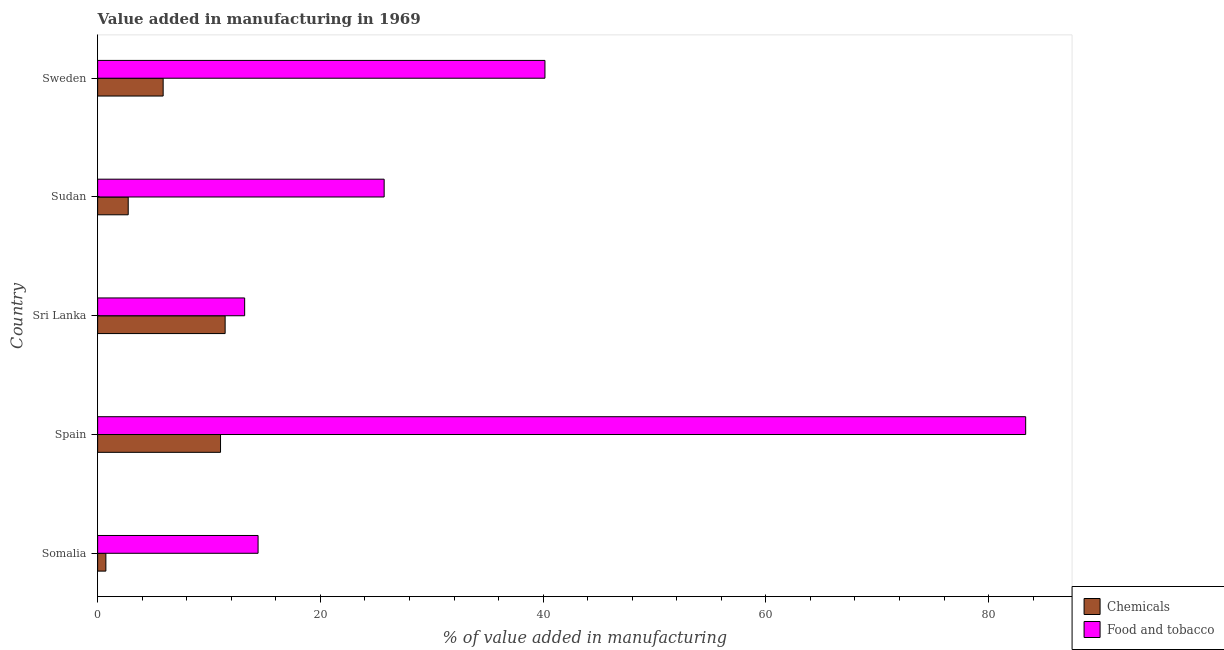How many different coloured bars are there?
Offer a terse response. 2. How many groups of bars are there?
Make the answer very short. 5. What is the label of the 5th group of bars from the top?
Keep it short and to the point. Somalia. In how many cases, is the number of bars for a given country not equal to the number of legend labels?
Your answer should be very brief. 0. What is the value added by  manufacturing chemicals in Spain?
Keep it short and to the point. 11.03. Across all countries, what is the maximum value added by  manufacturing chemicals?
Offer a terse response. 11.45. Across all countries, what is the minimum value added by manufacturing food and tobacco?
Offer a terse response. 13.2. In which country was the value added by manufacturing food and tobacco maximum?
Provide a succinct answer. Spain. In which country was the value added by manufacturing food and tobacco minimum?
Provide a short and direct response. Sri Lanka. What is the total value added by  manufacturing chemicals in the graph?
Your answer should be very brief. 31.85. What is the difference between the value added by manufacturing food and tobacco in Sri Lanka and that in Sweden?
Offer a very short reply. -26.96. What is the difference between the value added by manufacturing food and tobacco in Somalia and the value added by  manufacturing chemicals in Sudan?
Give a very brief answer. 11.66. What is the average value added by  manufacturing chemicals per country?
Provide a succinct answer. 6.37. What is the difference between the value added by  manufacturing chemicals and value added by manufacturing food and tobacco in Sri Lanka?
Your answer should be compact. -1.75. In how many countries, is the value added by manufacturing food and tobacco greater than 60 %?
Give a very brief answer. 1. What is the ratio of the value added by  manufacturing chemicals in Sudan to that in Sweden?
Provide a succinct answer. 0.47. Is the difference between the value added by  manufacturing chemicals in Spain and Sudan greater than the difference between the value added by manufacturing food and tobacco in Spain and Sudan?
Offer a very short reply. No. What is the difference between the highest and the second highest value added by manufacturing food and tobacco?
Provide a succinct answer. 43.16. What is the difference between the highest and the lowest value added by manufacturing food and tobacco?
Offer a very short reply. 70.12. What does the 1st bar from the top in Somalia represents?
Offer a terse response. Food and tobacco. What does the 2nd bar from the bottom in Sri Lanka represents?
Ensure brevity in your answer.  Food and tobacco. How many countries are there in the graph?
Offer a very short reply. 5. Does the graph contain any zero values?
Provide a succinct answer. No. Does the graph contain grids?
Provide a succinct answer. No. Where does the legend appear in the graph?
Ensure brevity in your answer.  Bottom right. How many legend labels are there?
Give a very brief answer. 2. How are the legend labels stacked?
Keep it short and to the point. Vertical. What is the title of the graph?
Offer a terse response. Value added in manufacturing in 1969. Does "Drinking water services" appear as one of the legend labels in the graph?
Offer a terse response. No. What is the label or title of the X-axis?
Offer a very short reply. % of value added in manufacturing. What is the label or title of the Y-axis?
Your answer should be compact. Country. What is the % of value added in manufacturing in Chemicals in Somalia?
Your answer should be very brief. 0.74. What is the % of value added in manufacturing of Food and tobacco in Somalia?
Make the answer very short. 14.41. What is the % of value added in manufacturing of Chemicals in Spain?
Keep it short and to the point. 11.03. What is the % of value added in manufacturing of Food and tobacco in Spain?
Provide a succinct answer. 83.33. What is the % of value added in manufacturing in Chemicals in Sri Lanka?
Provide a short and direct response. 11.45. What is the % of value added in manufacturing of Food and tobacco in Sri Lanka?
Make the answer very short. 13.2. What is the % of value added in manufacturing in Chemicals in Sudan?
Provide a short and direct response. 2.75. What is the % of value added in manufacturing in Food and tobacco in Sudan?
Make the answer very short. 25.73. What is the % of value added in manufacturing in Chemicals in Sweden?
Your answer should be compact. 5.88. What is the % of value added in manufacturing of Food and tobacco in Sweden?
Your response must be concise. 40.16. Across all countries, what is the maximum % of value added in manufacturing of Chemicals?
Your answer should be compact. 11.45. Across all countries, what is the maximum % of value added in manufacturing in Food and tobacco?
Keep it short and to the point. 83.33. Across all countries, what is the minimum % of value added in manufacturing of Chemicals?
Offer a terse response. 0.74. Across all countries, what is the minimum % of value added in manufacturing of Food and tobacco?
Ensure brevity in your answer.  13.2. What is the total % of value added in manufacturing of Chemicals in the graph?
Give a very brief answer. 31.85. What is the total % of value added in manufacturing in Food and tobacco in the graph?
Provide a succinct answer. 176.82. What is the difference between the % of value added in manufacturing in Chemicals in Somalia and that in Spain?
Provide a succinct answer. -10.29. What is the difference between the % of value added in manufacturing of Food and tobacco in Somalia and that in Spain?
Keep it short and to the point. -68.92. What is the difference between the % of value added in manufacturing in Chemicals in Somalia and that in Sri Lanka?
Ensure brevity in your answer.  -10.71. What is the difference between the % of value added in manufacturing of Food and tobacco in Somalia and that in Sri Lanka?
Your answer should be very brief. 1.2. What is the difference between the % of value added in manufacturing in Chemicals in Somalia and that in Sudan?
Provide a short and direct response. -2.01. What is the difference between the % of value added in manufacturing of Food and tobacco in Somalia and that in Sudan?
Your response must be concise. -11.32. What is the difference between the % of value added in manufacturing of Chemicals in Somalia and that in Sweden?
Your answer should be very brief. -5.14. What is the difference between the % of value added in manufacturing in Food and tobacco in Somalia and that in Sweden?
Ensure brevity in your answer.  -25.76. What is the difference between the % of value added in manufacturing of Chemicals in Spain and that in Sri Lanka?
Provide a short and direct response. -0.41. What is the difference between the % of value added in manufacturing of Food and tobacco in Spain and that in Sri Lanka?
Keep it short and to the point. 70.12. What is the difference between the % of value added in manufacturing in Chemicals in Spain and that in Sudan?
Offer a very short reply. 8.29. What is the difference between the % of value added in manufacturing in Food and tobacco in Spain and that in Sudan?
Offer a terse response. 57.6. What is the difference between the % of value added in manufacturing of Chemicals in Spain and that in Sweden?
Provide a short and direct response. 5.15. What is the difference between the % of value added in manufacturing of Food and tobacco in Spain and that in Sweden?
Give a very brief answer. 43.16. What is the difference between the % of value added in manufacturing in Chemicals in Sri Lanka and that in Sudan?
Make the answer very short. 8.7. What is the difference between the % of value added in manufacturing in Food and tobacco in Sri Lanka and that in Sudan?
Offer a very short reply. -12.53. What is the difference between the % of value added in manufacturing in Chemicals in Sri Lanka and that in Sweden?
Your answer should be compact. 5.57. What is the difference between the % of value added in manufacturing of Food and tobacco in Sri Lanka and that in Sweden?
Your answer should be very brief. -26.96. What is the difference between the % of value added in manufacturing of Chemicals in Sudan and that in Sweden?
Give a very brief answer. -3.14. What is the difference between the % of value added in manufacturing of Food and tobacco in Sudan and that in Sweden?
Your answer should be very brief. -14.44. What is the difference between the % of value added in manufacturing in Chemicals in Somalia and the % of value added in manufacturing in Food and tobacco in Spain?
Your answer should be very brief. -82.59. What is the difference between the % of value added in manufacturing of Chemicals in Somalia and the % of value added in manufacturing of Food and tobacco in Sri Lanka?
Offer a terse response. -12.46. What is the difference between the % of value added in manufacturing in Chemicals in Somalia and the % of value added in manufacturing in Food and tobacco in Sudan?
Offer a terse response. -24.99. What is the difference between the % of value added in manufacturing of Chemicals in Somalia and the % of value added in manufacturing of Food and tobacco in Sweden?
Offer a very short reply. -39.42. What is the difference between the % of value added in manufacturing of Chemicals in Spain and the % of value added in manufacturing of Food and tobacco in Sri Lanka?
Offer a terse response. -2.17. What is the difference between the % of value added in manufacturing in Chemicals in Spain and the % of value added in manufacturing in Food and tobacco in Sudan?
Your response must be concise. -14.69. What is the difference between the % of value added in manufacturing of Chemicals in Spain and the % of value added in manufacturing of Food and tobacco in Sweden?
Give a very brief answer. -29.13. What is the difference between the % of value added in manufacturing in Chemicals in Sri Lanka and the % of value added in manufacturing in Food and tobacco in Sudan?
Your answer should be compact. -14.28. What is the difference between the % of value added in manufacturing of Chemicals in Sri Lanka and the % of value added in manufacturing of Food and tobacco in Sweden?
Your answer should be compact. -28.71. What is the difference between the % of value added in manufacturing of Chemicals in Sudan and the % of value added in manufacturing of Food and tobacco in Sweden?
Provide a short and direct response. -37.42. What is the average % of value added in manufacturing of Chemicals per country?
Your answer should be very brief. 6.37. What is the average % of value added in manufacturing in Food and tobacco per country?
Ensure brevity in your answer.  35.36. What is the difference between the % of value added in manufacturing of Chemicals and % of value added in manufacturing of Food and tobacco in Somalia?
Your response must be concise. -13.67. What is the difference between the % of value added in manufacturing in Chemicals and % of value added in manufacturing in Food and tobacco in Spain?
Provide a short and direct response. -72.29. What is the difference between the % of value added in manufacturing in Chemicals and % of value added in manufacturing in Food and tobacco in Sri Lanka?
Make the answer very short. -1.75. What is the difference between the % of value added in manufacturing in Chemicals and % of value added in manufacturing in Food and tobacco in Sudan?
Make the answer very short. -22.98. What is the difference between the % of value added in manufacturing in Chemicals and % of value added in manufacturing in Food and tobacco in Sweden?
Make the answer very short. -34.28. What is the ratio of the % of value added in manufacturing in Chemicals in Somalia to that in Spain?
Offer a terse response. 0.07. What is the ratio of the % of value added in manufacturing of Food and tobacco in Somalia to that in Spain?
Provide a succinct answer. 0.17. What is the ratio of the % of value added in manufacturing of Chemicals in Somalia to that in Sri Lanka?
Keep it short and to the point. 0.06. What is the ratio of the % of value added in manufacturing in Food and tobacco in Somalia to that in Sri Lanka?
Your response must be concise. 1.09. What is the ratio of the % of value added in manufacturing in Chemicals in Somalia to that in Sudan?
Provide a succinct answer. 0.27. What is the ratio of the % of value added in manufacturing in Food and tobacco in Somalia to that in Sudan?
Your answer should be very brief. 0.56. What is the ratio of the % of value added in manufacturing in Chemicals in Somalia to that in Sweden?
Your answer should be very brief. 0.13. What is the ratio of the % of value added in manufacturing of Food and tobacco in Somalia to that in Sweden?
Provide a succinct answer. 0.36. What is the ratio of the % of value added in manufacturing of Chemicals in Spain to that in Sri Lanka?
Provide a short and direct response. 0.96. What is the ratio of the % of value added in manufacturing in Food and tobacco in Spain to that in Sri Lanka?
Your answer should be very brief. 6.31. What is the ratio of the % of value added in manufacturing of Chemicals in Spain to that in Sudan?
Keep it short and to the point. 4.02. What is the ratio of the % of value added in manufacturing in Food and tobacco in Spain to that in Sudan?
Make the answer very short. 3.24. What is the ratio of the % of value added in manufacturing of Chemicals in Spain to that in Sweden?
Give a very brief answer. 1.88. What is the ratio of the % of value added in manufacturing of Food and tobacco in Spain to that in Sweden?
Provide a short and direct response. 2.07. What is the ratio of the % of value added in manufacturing of Chemicals in Sri Lanka to that in Sudan?
Provide a succinct answer. 4.17. What is the ratio of the % of value added in manufacturing in Food and tobacco in Sri Lanka to that in Sudan?
Offer a terse response. 0.51. What is the ratio of the % of value added in manufacturing in Chemicals in Sri Lanka to that in Sweden?
Provide a succinct answer. 1.95. What is the ratio of the % of value added in manufacturing of Food and tobacco in Sri Lanka to that in Sweden?
Provide a short and direct response. 0.33. What is the ratio of the % of value added in manufacturing in Chemicals in Sudan to that in Sweden?
Your response must be concise. 0.47. What is the ratio of the % of value added in manufacturing in Food and tobacco in Sudan to that in Sweden?
Make the answer very short. 0.64. What is the difference between the highest and the second highest % of value added in manufacturing in Chemicals?
Your response must be concise. 0.41. What is the difference between the highest and the second highest % of value added in manufacturing of Food and tobacco?
Offer a very short reply. 43.16. What is the difference between the highest and the lowest % of value added in manufacturing of Chemicals?
Offer a terse response. 10.71. What is the difference between the highest and the lowest % of value added in manufacturing of Food and tobacco?
Keep it short and to the point. 70.12. 